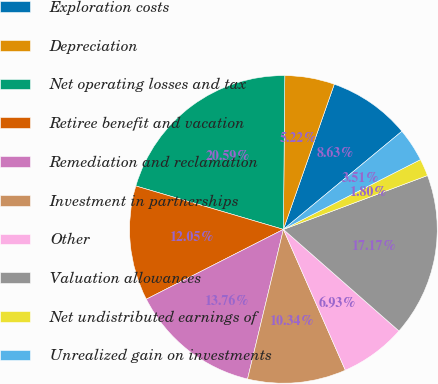Convert chart. <chart><loc_0><loc_0><loc_500><loc_500><pie_chart><fcel>Exploration costs<fcel>Depreciation<fcel>Net operating losses and tax<fcel>Retiree benefit and vacation<fcel>Remediation and reclamation<fcel>Investment in partnerships<fcel>Other<fcel>Valuation allowances<fcel>Net undistributed earnings of<fcel>Unrealized gain on investments<nl><fcel>8.63%<fcel>5.22%<fcel>20.59%<fcel>12.05%<fcel>13.76%<fcel>10.34%<fcel>6.93%<fcel>17.17%<fcel>1.8%<fcel>3.51%<nl></chart> 